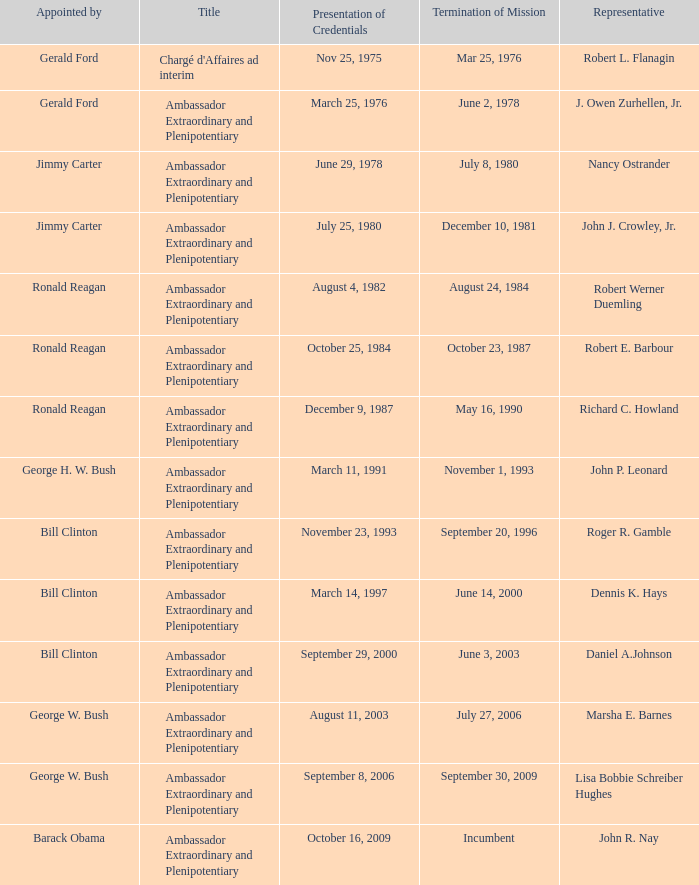Who appointed the representative that had a Presentation of Credentials on March 25, 1976? Gerald Ford. 